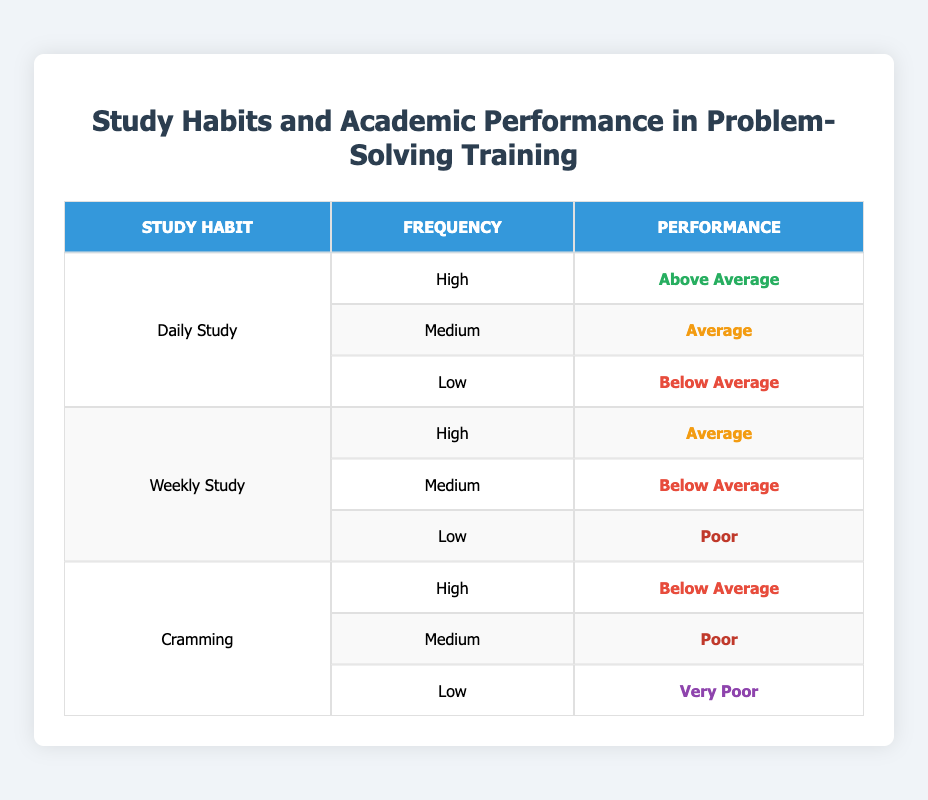What is the performance level of students who study daily with high frequency? Referring to the table, the only entry for "Daily Study" under "High" frequency indicates a performance labeled as "Above Average."
Answer: Above Average How many performance levels correspond to the "Weekly Study" habit? There are three performance levels associated with "Weekly Study": "Average," "Below Average," and "Poor." Counting these provides a total of three distinct levels.
Answer: 3 Is it true that all cramming students had below-average performance? Checking the performance levels for "Cramming," we see that the highest performance level is "Below Average," indicating that students who cram do not reach an above-average performance level. Therefore, the statement is true.
Answer: Yes What is the performance of students with low frequency in "Weekly Study"? According to the table, under "Weekly Study" with "Low" frequency, the performance level is marked as "Poor."
Answer: Poor What are the average performance levels for students who study daily compared to those who cram? For "Daily Study," performances are "Above Average," "Average," and "Below Average," while for "Cramming," performances are "Below Average," "Poor," and "Very Poor." Summarizing these levels, we can assign rough averages: "Daily Study" averages higher than "Cramming." Based on a general perspective, we can claim "Daily Study" is better.
Answer: Daily Study is better What is the difference in performance between "Weekly Study" at low frequency and "Cramming" at high frequency? For "Weekly Study" at low frequency, the performance is "Poor," while for "Cramming" at high frequency, the performance is "Below Average." Considering the ranking from poorest to best performance, "Poor" ranks lower than "Below Average." The difference is a distinction in naming rather than in performance ranking.
Answer: Poor is lower From the data, which study habit shows the best performance? The study habits are ranked based on performance. "Daily Study" with "High" frequency has the top performance level, classified as "Above Average." This clearly places it as the best performing study habit out of those listed.
Answer: Daily Study What can be inferred about students who cram and their academic performance? Students who engage in cramming frequently have performance levels at "Below Average," "Poor," and "Very Poor." This indicates that cramming is not an effective study technique leading to better academic performance.
Answer: Cramming is ineffective 